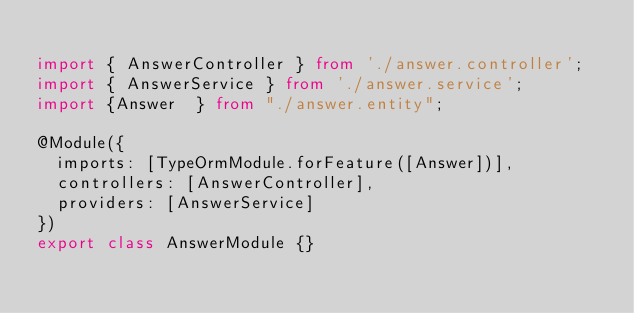<code> <loc_0><loc_0><loc_500><loc_500><_TypeScript_>
import { AnswerController } from './answer.controller';
import { AnswerService } from './answer.service';
import {Answer  } from "./answer.entity";

@Module({
  imports: [TypeOrmModule.forFeature([Answer])],
  controllers: [AnswerController],
  providers: [AnswerService]
})
export class AnswerModule {}
</code> 